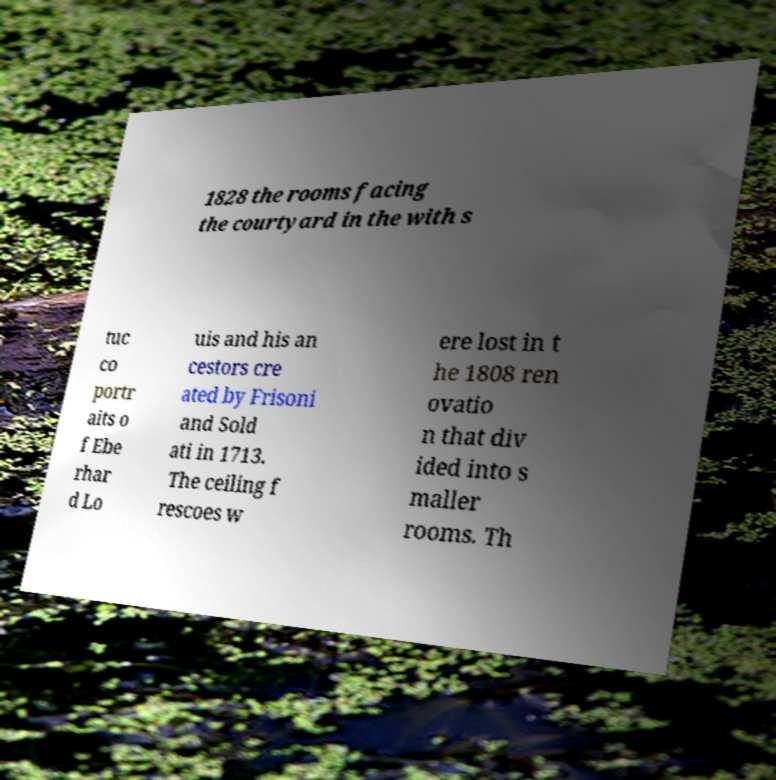What messages or text are displayed in this image? I need them in a readable, typed format. 1828 the rooms facing the courtyard in the with s tuc co portr aits o f Ebe rhar d Lo uis and his an cestors cre ated by Frisoni and Sold ati in 1713. The ceiling f rescoes w ere lost in t he 1808 ren ovatio n that div ided into s maller rooms. Th 